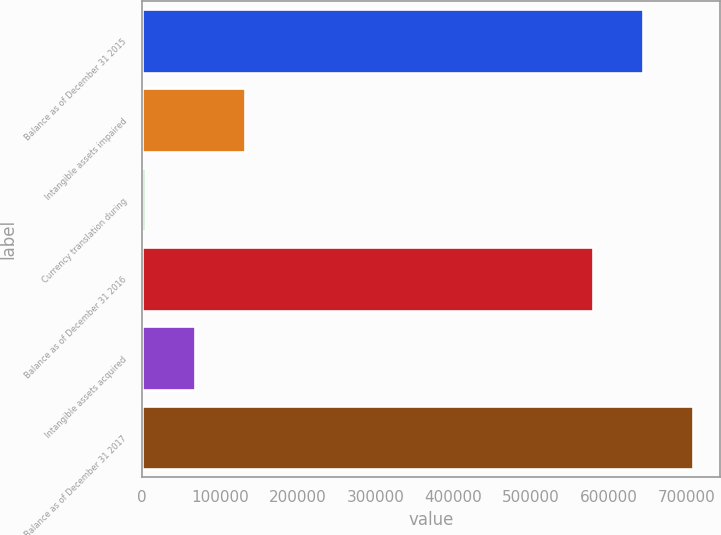Convert chart to OTSL. <chart><loc_0><loc_0><loc_500><loc_500><bar_chart><fcel>Balance as of December 31 2015<fcel>Intangible assets impaired<fcel>Currency translation during<fcel>Balance as of December 31 2016<fcel>Intangible assets acquired<fcel>Balance as of December 31 2017<nl><fcel>644138<fcel>132279<fcel>4297<fcel>580147<fcel>68288.1<fcel>708129<nl></chart> 